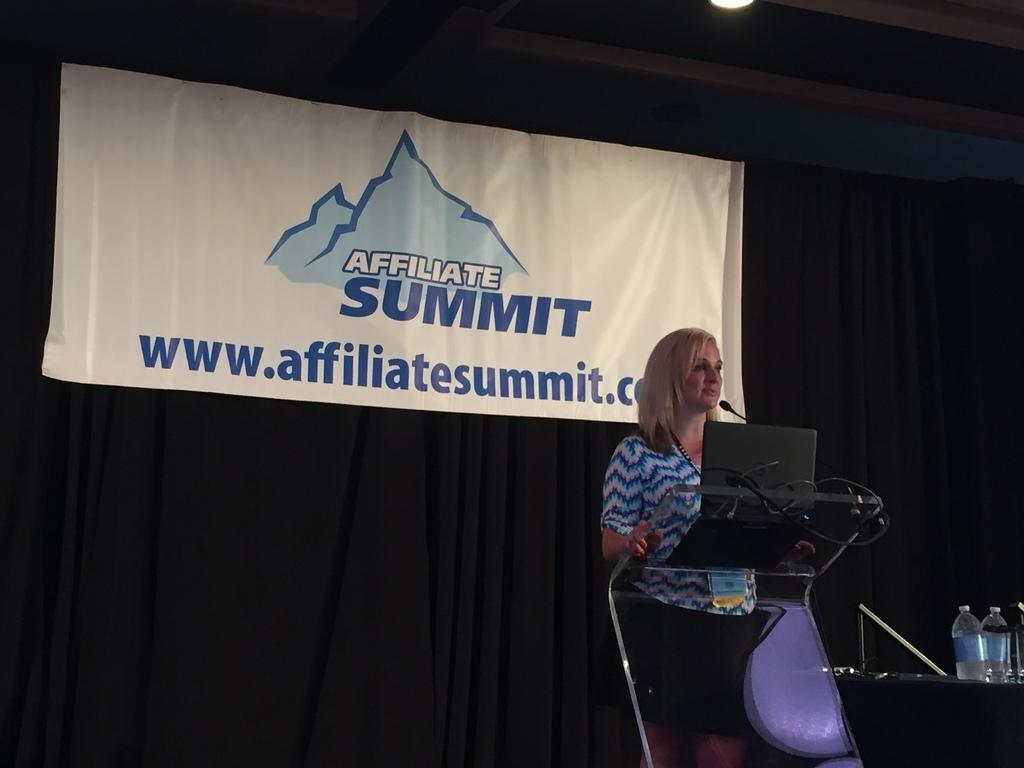<image>
Write a terse but informative summary of the picture. A blonde woman is speaking on a stage and a white banner behind her says Affiliate Summit. 